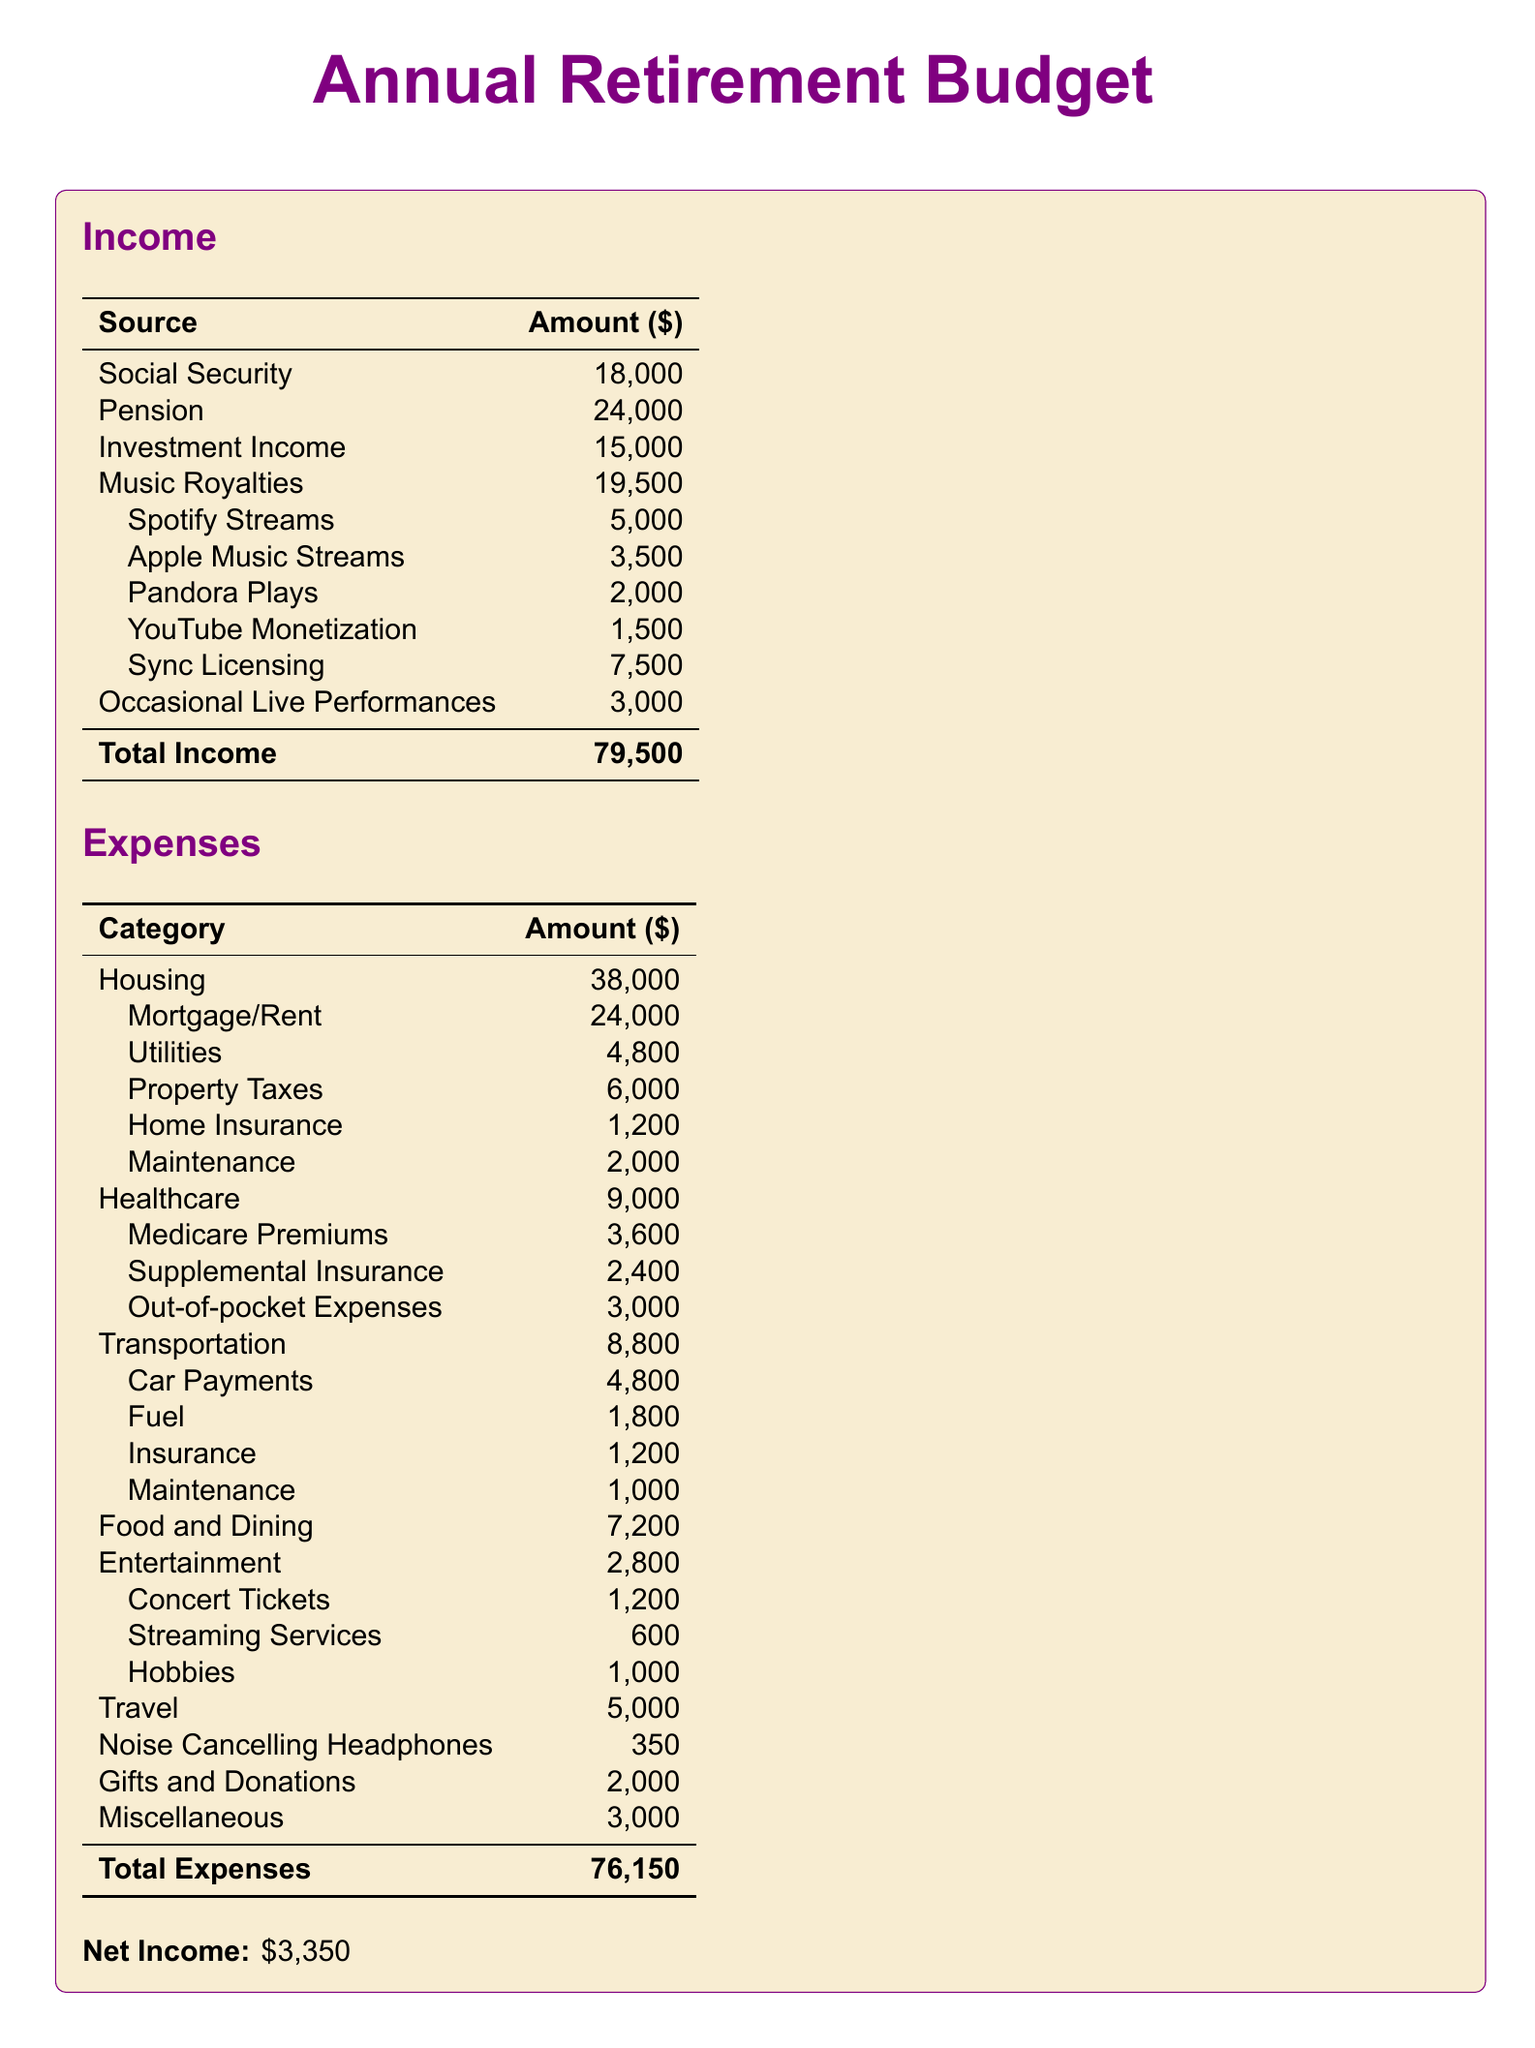What is the total income? The total income is listed at the bottom of the income section in the document, which sums up all the sources of income.
Answer: 79,500 How much do music royalties contribute to the income? The document specifies the amount earned from music royalties as part of the total income breakdown.
Answer: 19,500 Which source generates the highest income from music? The document details various sources of music royalties, and the highest amount listed is from sync licensing.
Answer: 7,500 What are the total expenses? The total expenses are highlighted at the bottom of the expenses section in the document as the summation of all listed expenses.
Answer: 76,150 What is the net income? The net income is calculated by subtracting total expenses from total income and is stated in the document.
Answer: 3,350 How much is spent on healthcare? The healthcare expenses are broken down in the relevant section, and the total amount is clearly indicated.
Answer: 9,000 How much do noise-cancelling headphones cost? The document lists the cost of noise-cancelling headphones under the expenses category.
Answer: 350 What percentage of total income comes from Social Security? To find this, divide the Social Security amount by the total income and multiply by 100; it requires some calculation based on the values provided.
Answer: 22.6% What is the total from occasional live performances? The document mentions occasional live performances as a source of income and specifies the amount earned.
Answer: 3,000 